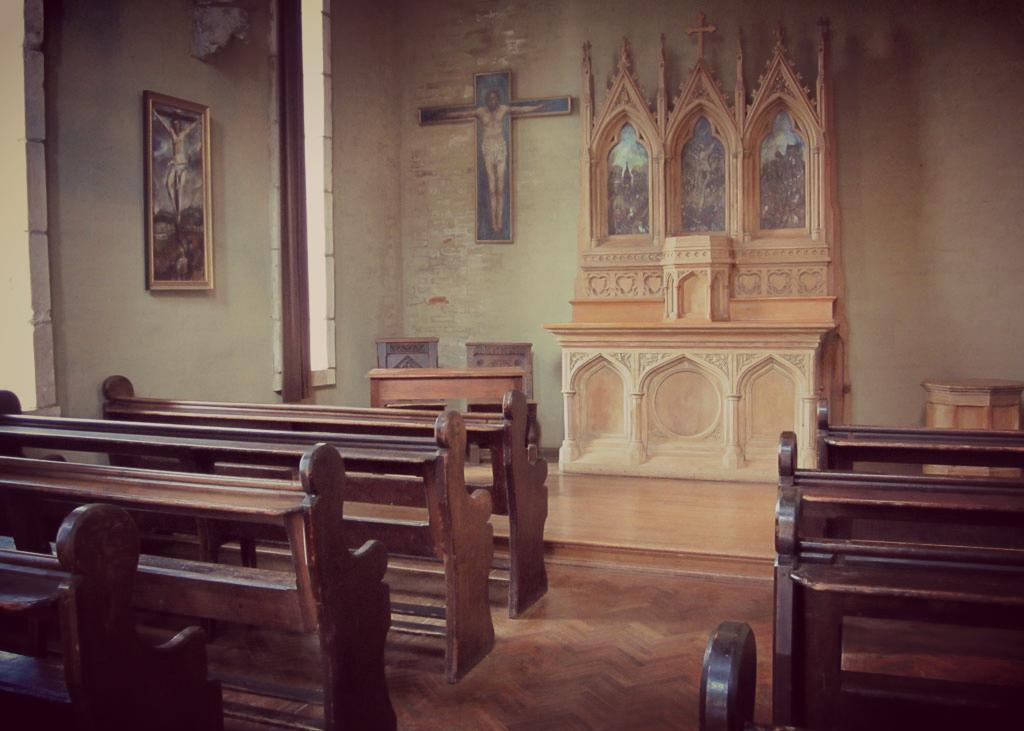What type of building is the image taken inside? The image is inside a church. What type of seating is available in the church? There are wooden benches in the image. What can be seen hanging on the wall in the image? There is a photo frame on the wall in the image. What religious symbol is attached to the wall in the image? There is a cross symbol attached to the wall in the image. How many boys are playing in the spring in the image? There are no boys or springs present in the image; it is taken inside a church. 